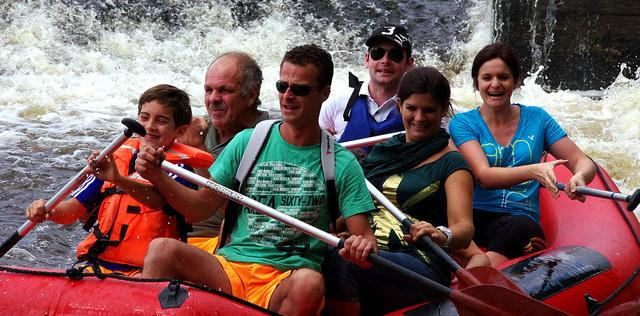What safety item is the person in Green and blue shirts missing? life jacket 